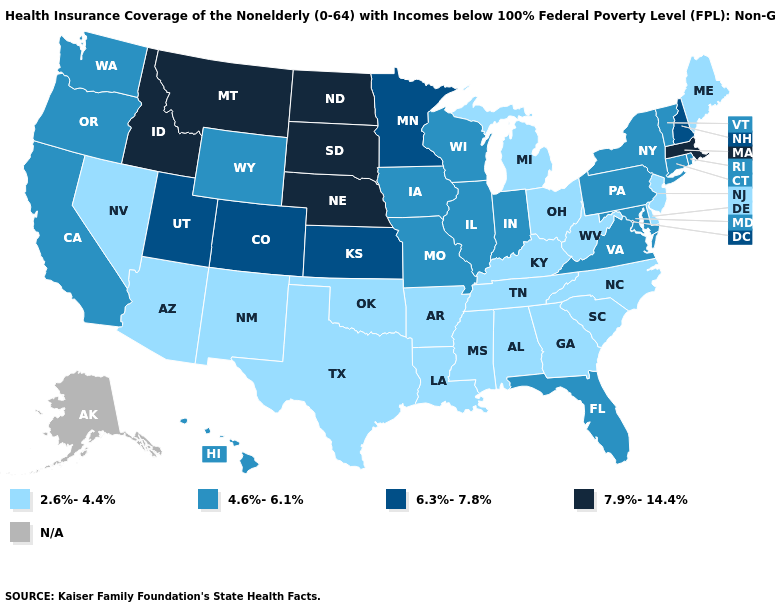Name the states that have a value in the range 4.6%-6.1%?
Be succinct. California, Connecticut, Florida, Hawaii, Illinois, Indiana, Iowa, Maryland, Missouri, New York, Oregon, Pennsylvania, Rhode Island, Vermont, Virginia, Washington, Wisconsin, Wyoming. What is the value of Hawaii?
Be succinct. 4.6%-6.1%. What is the value of West Virginia?
Keep it brief. 2.6%-4.4%. What is the value of Louisiana?
Short answer required. 2.6%-4.4%. Does Vermont have the lowest value in the Northeast?
Short answer required. No. Does New Hampshire have the lowest value in the USA?
Be succinct. No. Name the states that have a value in the range 6.3%-7.8%?
Short answer required. Colorado, Kansas, Minnesota, New Hampshire, Utah. What is the value of Nebraska?
Short answer required. 7.9%-14.4%. Name the states that have a value in the range 4.6%-6.1%?
Quick response, please. California, Connecticut, Florida, Hawaii, Illinois, Indiana, Iowa, Maryland, Missouri, New York, Oregon, Pennsylvania, Rhode Island, Vermont, Virginia, Washington, Wisconsin, Wyoming. What is the value of California?
Short answer required. 4.6%-6.1%. Among the states that border New Hampshire , does Massachusetts have the highest value?
Give a very brief answer. Yes. Among the states that border Illinois , which have the highest value?
Be succinct. Indiana, Iowa, Missouri, Wisconsin. Which states have the highest value in the USA?
Give a very brief answer. Idaho, Massachusetts, Montana, Nebraska, North Dakota, South Dakota. 